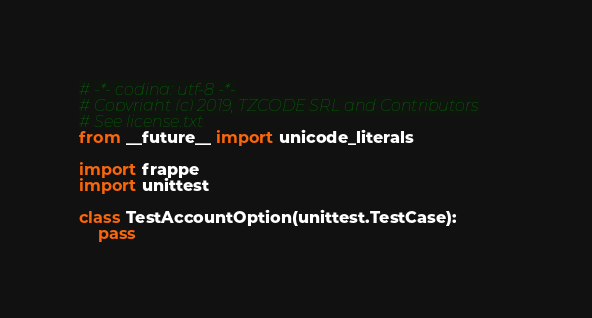<code> <loc_0><loc_0><loc_500><loc_500><_Python_># -*- coding: utf-8 -*-
# Copyright (c) 2019, TZCODE SRL and Contributors
# See license.txt
from __future__ import unicode_literals

import frappe
import unittest

class TestAccountOption(unittest.TestCase):
	pass
</code> 